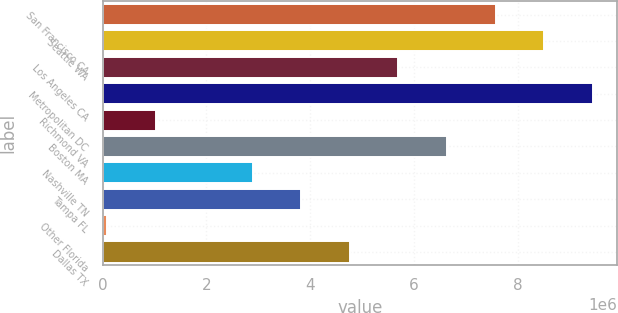Convert chart. <chart><loc_0><loc_0><loc_500><loc_500><bar_chart><fcel>San Francisco CA<fcel>Seattle WA<fcel>Los Angeles CA<fcel>Metropolitan DC<fcel>Richmond VA<fcel>Boston MA<fcel>Nashville TN<fcel>Tampa FL<fcel>Other Florida<fcel>Dallas TX<nl><fcel>7.57445e+06<fcel>8.51069e+06<fcel>5.70197e+06<fcel>9.44693e+06<fcel>1.02076e+06<fcel>6.63821e+06<fcel>2.89324e+06<fcel>3.82948e+06<fcel>84520<fcel>4.76573e+06<nl></chart> 